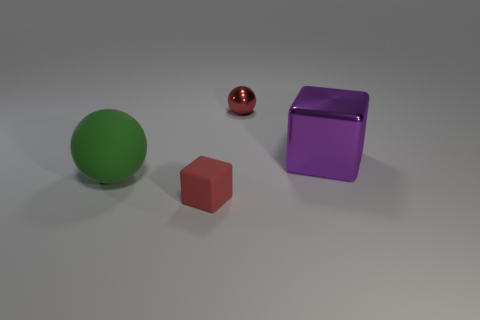Add 3 purple metallic cubes. How many objects exist? 7 Subtract 0 gray cylinders. How many objects are left? 4 Subtract all tiny cyan rubber cylinders. Subtract all purple metallic blocks. How many objects are left? 3 Add 2 big metal objects. How many big metal objects are left? 3 Add 4 big gray matte blocks. How many big gray matte blocks exist? 4 